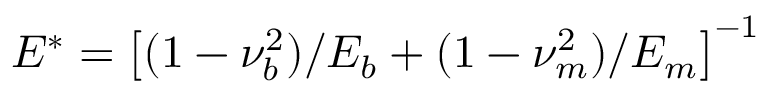<formula> <loc_0><loc_0><loc_500><loc_500>E ^ { * } = \left [ ( 1 - \nu _ { b } ^ { 2 } ) / E _ { b } + ( 1 - \nu _ { m } ^ { 2 } ) / E _ { m } \right ] ^ { - 1 }</formula> 